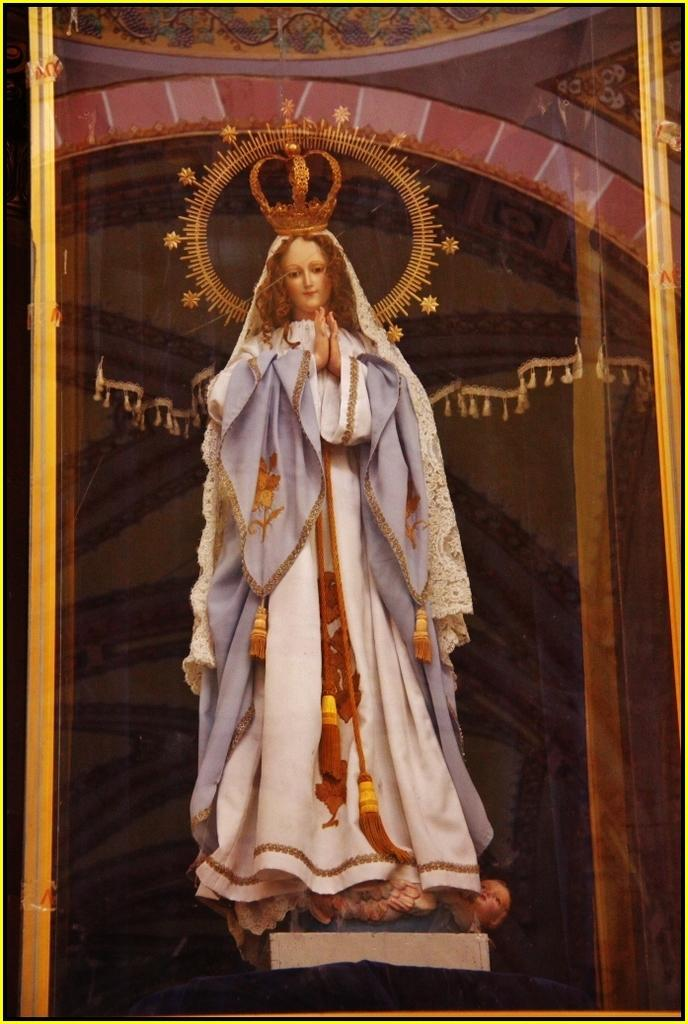What is the main subject in the foreground of the image? There is a goddess in the foreground of the image. What is the goddess wearing on her head? The goddess is wearing a crown on her head. What can be seen in the background of the image? There is a reflection of a hall visible in the image. What degree does the goddess hold in the image? The image does not provide information about the goddess's education or degrees. 